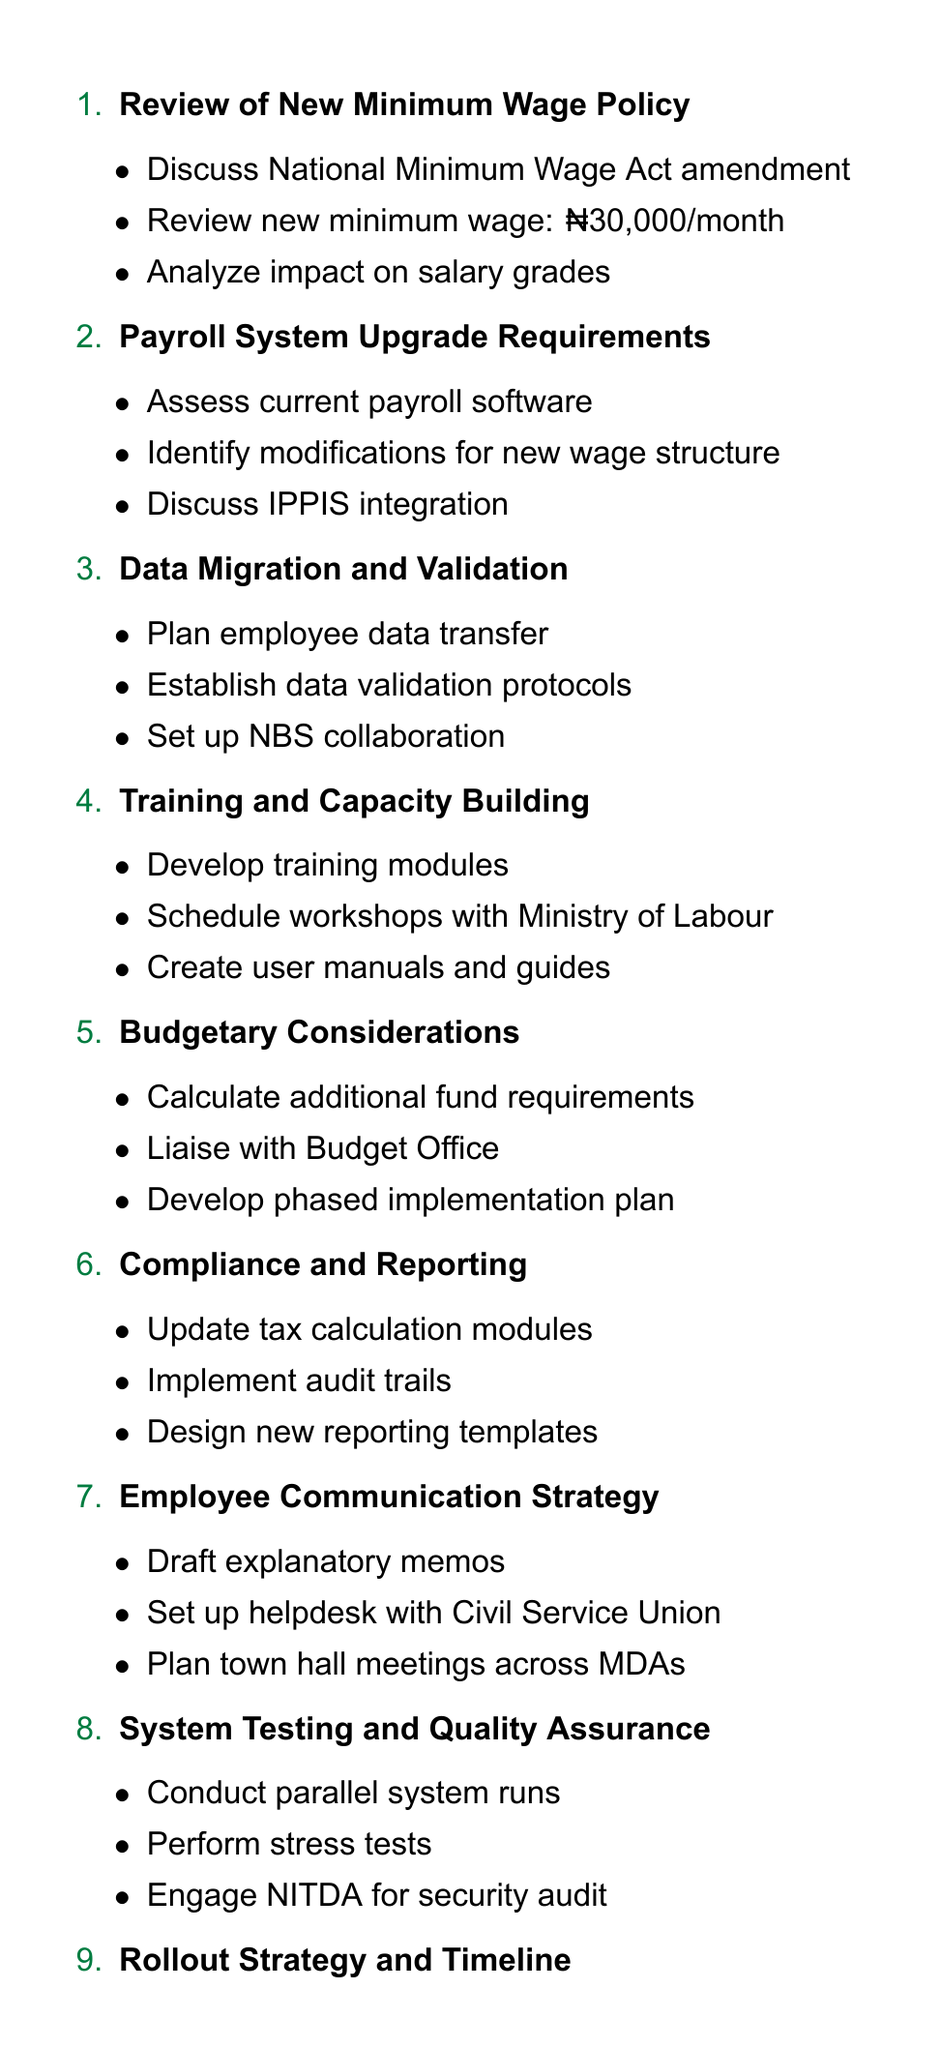What is the new minimum wage? The new minimum wage is directly stated in the document as ₦30,000 per month.
Answer: ₦30,000 per month How many agenda items are there? The document lists a total of ten agenda items, which can be counted in the enumeration section.
Answer: 10 What is the purpose of the Training and Capacity Building agenda item? This item specifically focuses on developing training modules and scheduling workshops for payroll officers to enhance their skills.
Answer: Develop training modules Which agency is responsible for security audit? The document mentions that NITDA is engaged for the security audit in the System Testing and Quality Assurance section.
Answer: NITDA What is the planned collaboration for data migration? The document specifies the need to collaborate with the National Bureau of Statistics for demographic data in the Data Migration and Validation agenda item.
Answer: National Bureau of Statistics What financial aspect is addressed under Budgetary Considerations? The document states that the agenda item is focused on calculating additional funds required from the Federal Government for the new payroll system.
Answer: Additional funds What is one of the key elements in the Employee Communication Strategy? The document outlines drafting memos to explain wage changes as part of the Employee Communication Strategy.
Answer: Draft memos Who will assist in the rollout strategy? The document indicates the Office of the Head of Civil Service will be involved in establishing the monitoring and evaluation framework.
Answer: Office of the Head of Civil Service What type of system will be tested in the System Testing and Quality Assurance agenda item? The document mentions conducting parallel runs with the old and new systems as part of the testing process.
Answer: Old and new systems 